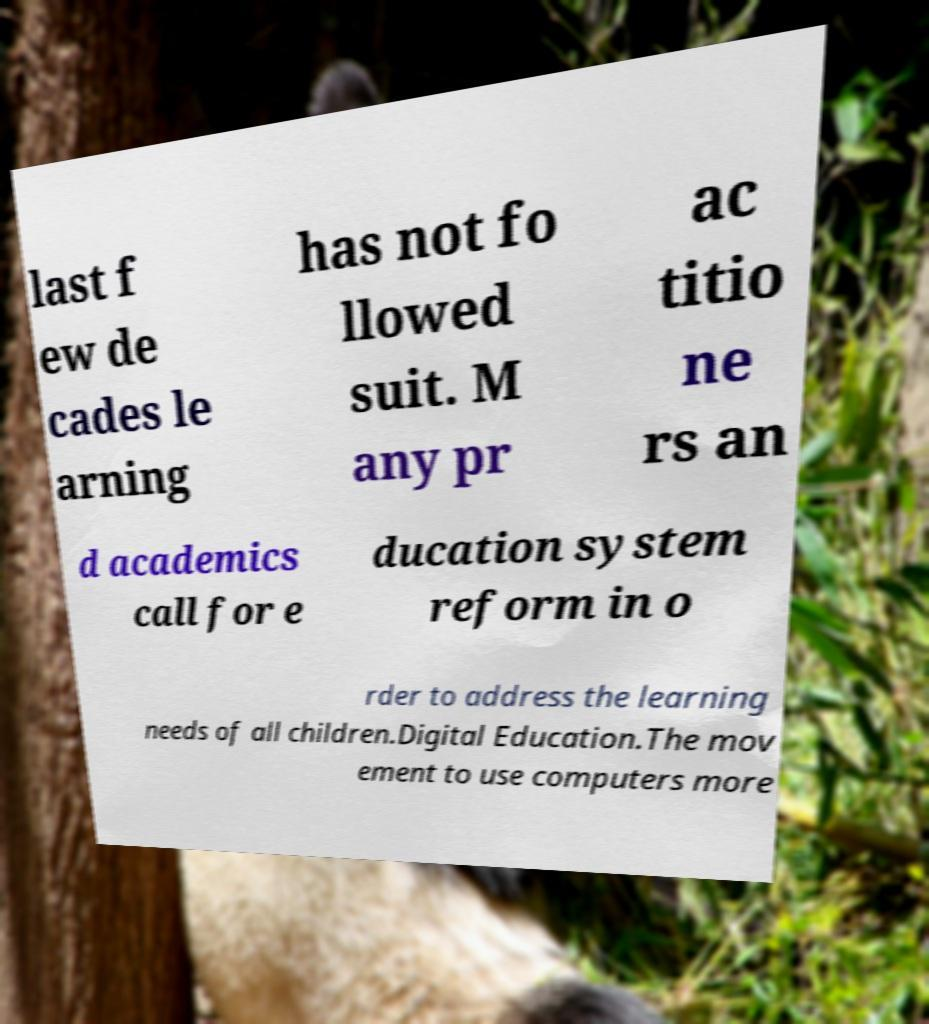Please identify and transcribe the text found in this image. last f ew de cades le arning has not fo llowed suit. M any pr ac titio ne rs an d academics call for e ducation system reform in o rder to address the learning needs of all children.Digital Education.The mov ement to use computers more 